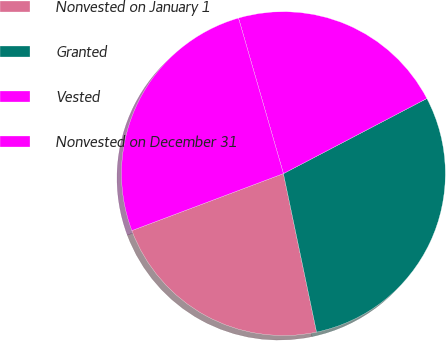Convert chart to OTSL. <chart><loc_0><loc_0><loc_500><loc_500><pie_chart><fcel>Nonvested on January 1<fcel>Granted<fcel>Vested<fcel>Nonvested on December 31<nl><fcel>22.56%<fcel>29.4%<fcel>21.8%<fcel>26.25%<nl></chart> 